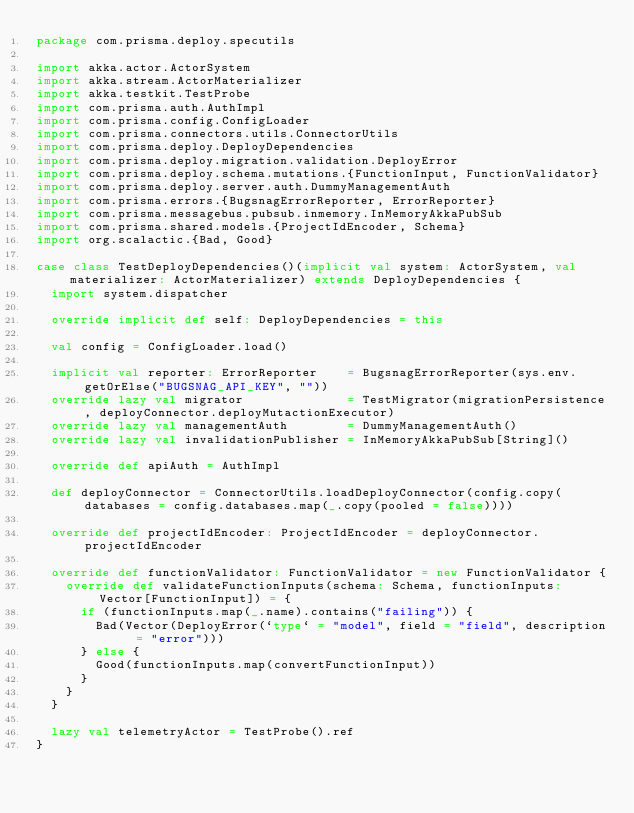Convert code to text. <code><loc_0><loc_0><loc_500><loc_500><_Scala_>package com.prisma.deploy.specutils

import akka.actor.ActorSystem
import akka.stream.ActorMaterializer
import akka.testkit.TestProbe
import com.prisma.auth.AuthImpl
import com.prisma.config.ConfigLoader
import com.prisma.connectors.utils.ConnectorUtils
import com.prisma.deploy.DeployDependencies
import com.prisma.deploy.migration.validation.DeployError
import com.prisma.deploy.schema.mutations.{FunctionInput, FunctionValidator}
import com.prisma.deploy.server.auth.DummyManagementAuth
import com.prisma.errors.{BugsnagErrorReporter, ErrorReporter}
import com.prisma.messagebus.pubsub.inmemory.InMemoryAkkaPubSub
import com.prisma.shared.models.{ProjectIdEncoder, Schema}
import org.scalactic.{Bad, Good}

case class TestDeployDependencies()(implicit val system: ActorSystem, val materializer: ActorMaterializer) extends DeployDependencies {
  import system.dispatcher

  override implicit def self: DeployDependencies = this

  val config = ConfigLoader.load()

  implicit val reporter: ErrorReporter    = BugsnagErrorReporter(sys.env.getOrElse("BUGSNAG_API_KEY", ""))
  override lazy val migrator              = TestMigrator(migrationPersistence, deployConnector.deployMutactionExecutor)
  override lazy val managementAuth        = DummyManagementAuth()
  override lazy val invalidationPublisher = InMemoryAkkaPubSub[String]()

  override def apiAuth = AuthImpl

  def deployConnector = ConnectorUtils.loadDeployConnector(config.copy(databases = config.databases.map(_.copy(pooled = false))))

  override def projectIdEncoder: ProjectIdEncoder = deployConnector.projectIdEncoder

  override def functionValidator: FunctionValidator = new FunctionValidator {
    override def validateFunctionInputs(schema: Schema, functionInputs: Vector[FunctionInput]) = {
      if (functionInputs.map(_.name).contains("failing")) {
        Bad(Vector(DeployError(`type` = "model", field = "field", description = "error")))
      } else {
        Good(functionInputs.map(convertFunctionInput))
      }
    }
  }

  lazy val telemetryActor = TestProbe().ref
}
</code> 